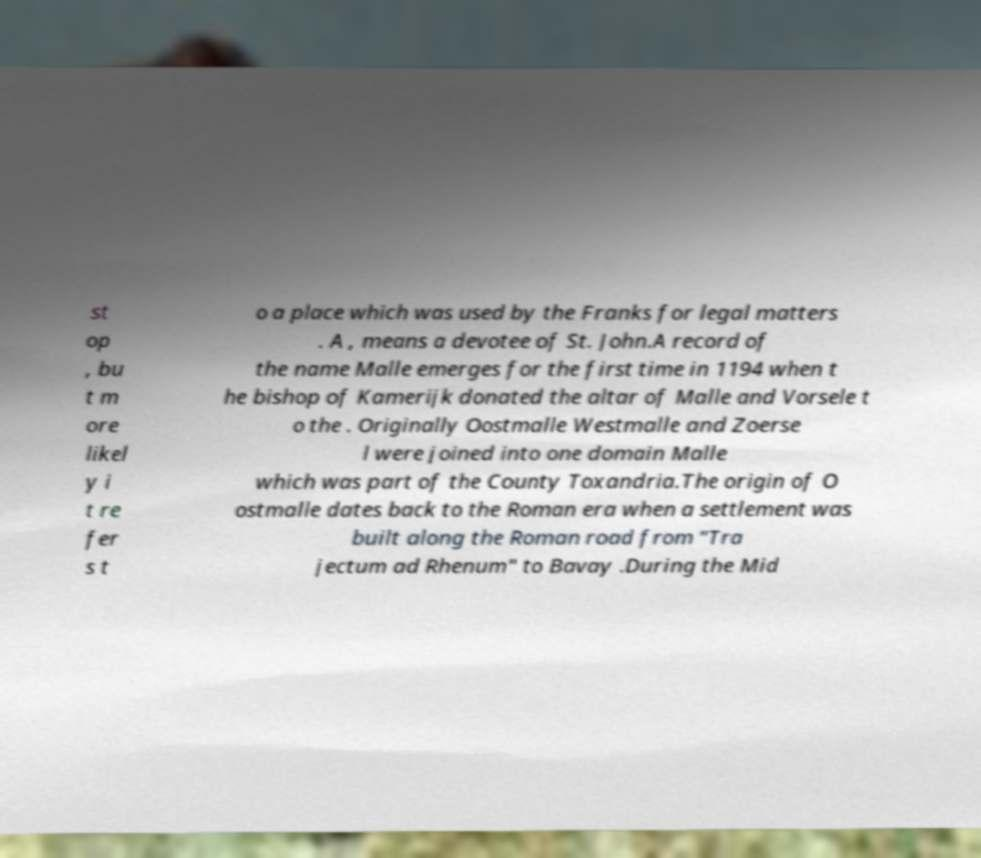Could you assist in decoding the text presented in this image and type it out clearly? st op , bu t m ore likel y i t re fer s t o a place which was used by the Franks for legal matters . A , means a devotee of St. John.A record of the name Malle emerges for the first time in 1194 when t he bishop of Kamerijk donated the altar of Malle and Vorsele t o the . Originally Oostmalle Westmalle and Zoerse l were joined into one domain Malle which was part of the County Toxandria.The origin of O ostmalle dates back to the Roman era when a settlement was built along the Roman road from "Tra jectum ad Rhenum" to Bavay .During the Mid 